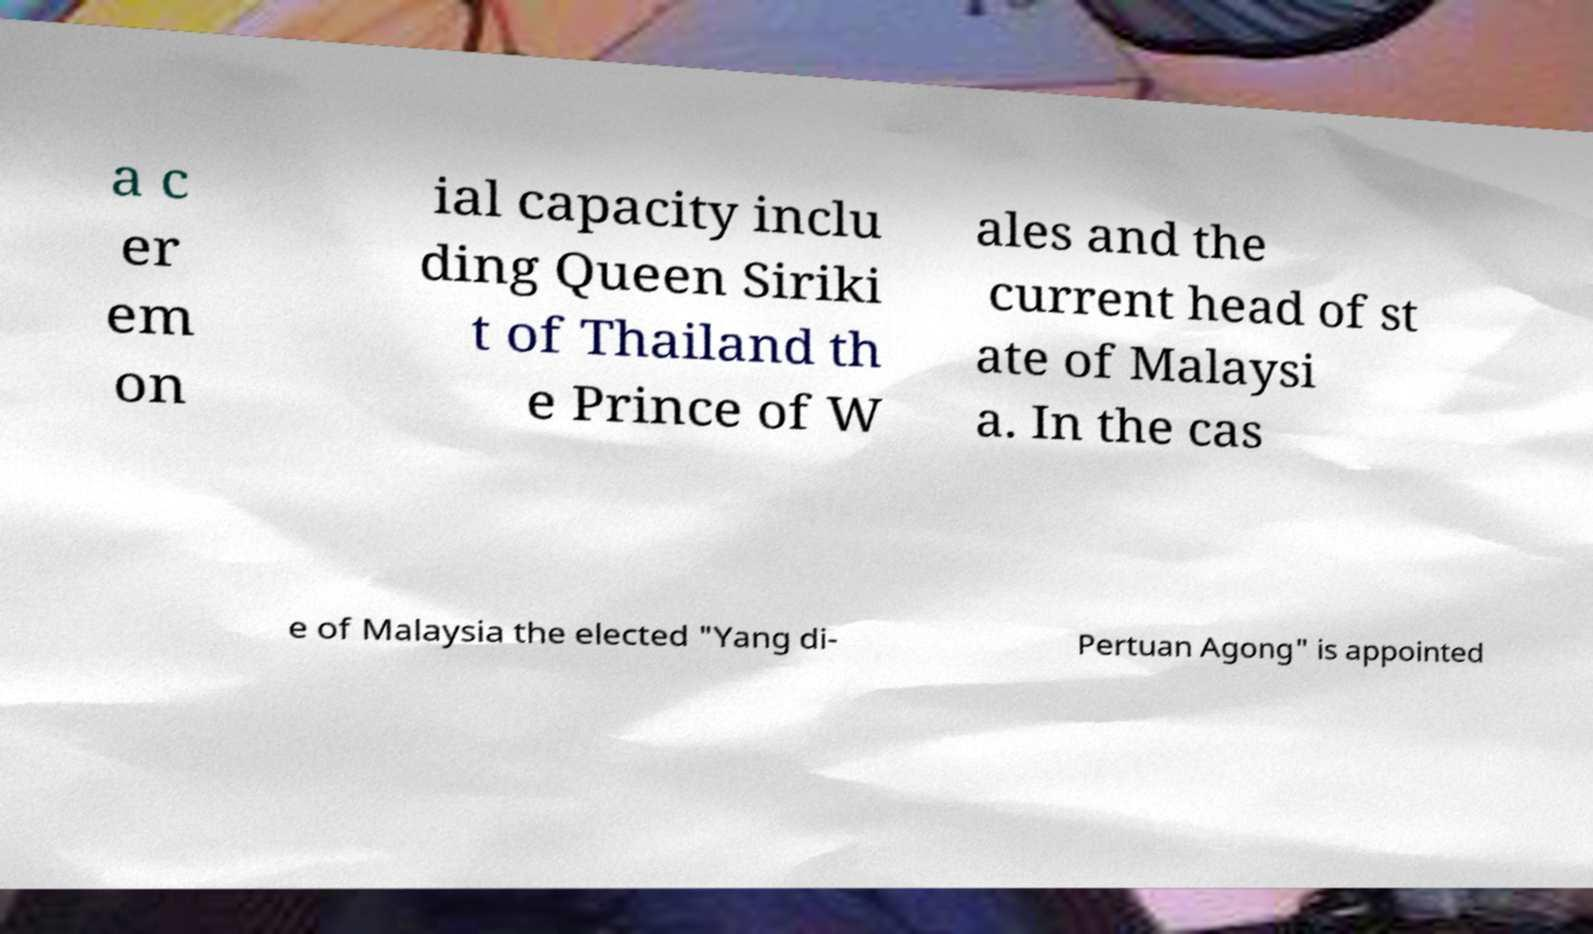I need the written content from this picture converted into text. Can you do that? a c er em on ial capacity inclu ding Queen Siriki t of Thailand th e Prince of W ales and the current head of st ate of Malaysi a. In the cas e of Malaysia the elected "Yang di- Pertuan Agong" is appointed 